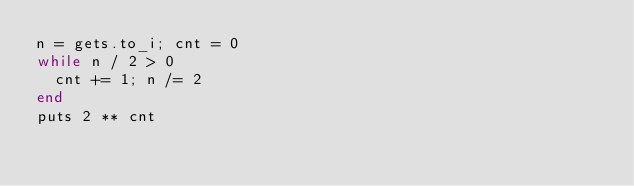Convert code to text. <code><loc_0><loc_0><loc_500><loc_500><_Ruby_>n = gets.to_i; cnt = 0
while n / 2 > 0
  cnt += 1; n /= 2
end
puts 2 ** cnt
</code> 